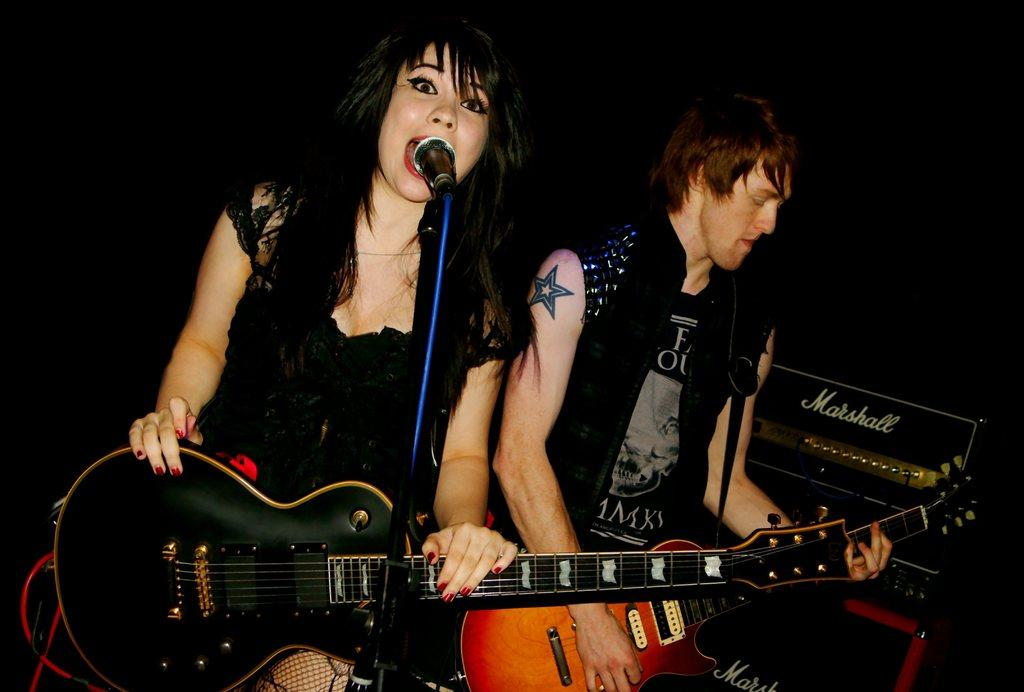How many people are in the image? There are two people in the image. Can you describe one of the people in the image? One of the people is a woman. What is the woman doing in the image? The woman is standing and holding a guitar. What is the woman doing with the guitar? The woman is singing into a microphone while holding the guitar. What type of lace can be seen on the woman's outfit in the image? There is no lace visible on the woman's outfit in the image. Can you tell me how many spoons are being used by the woman in the image? There are no spoons present in the image; the woman is holding a guitar and singing into a microphone. 